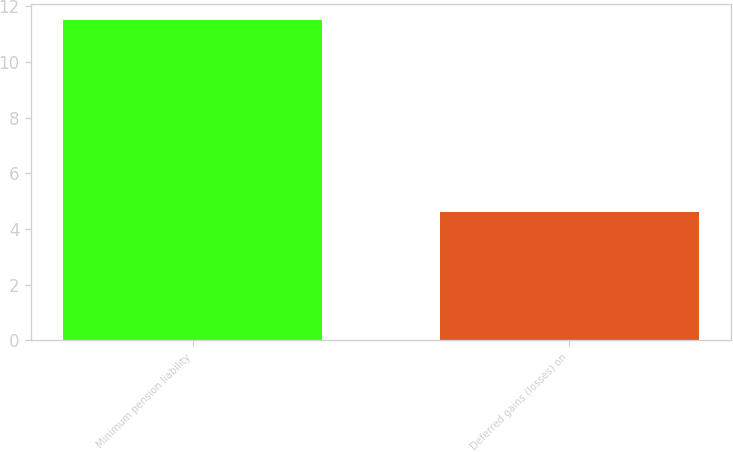Convert chart to OTSL. <chart><loc_0><loc_0><loc_500><loc_500><bar_chart><fcel>Minimum pension liability<fcel>Deferred gains (losses) on<nl><fcel>11.5<fcel>4.6<nl></chart> 